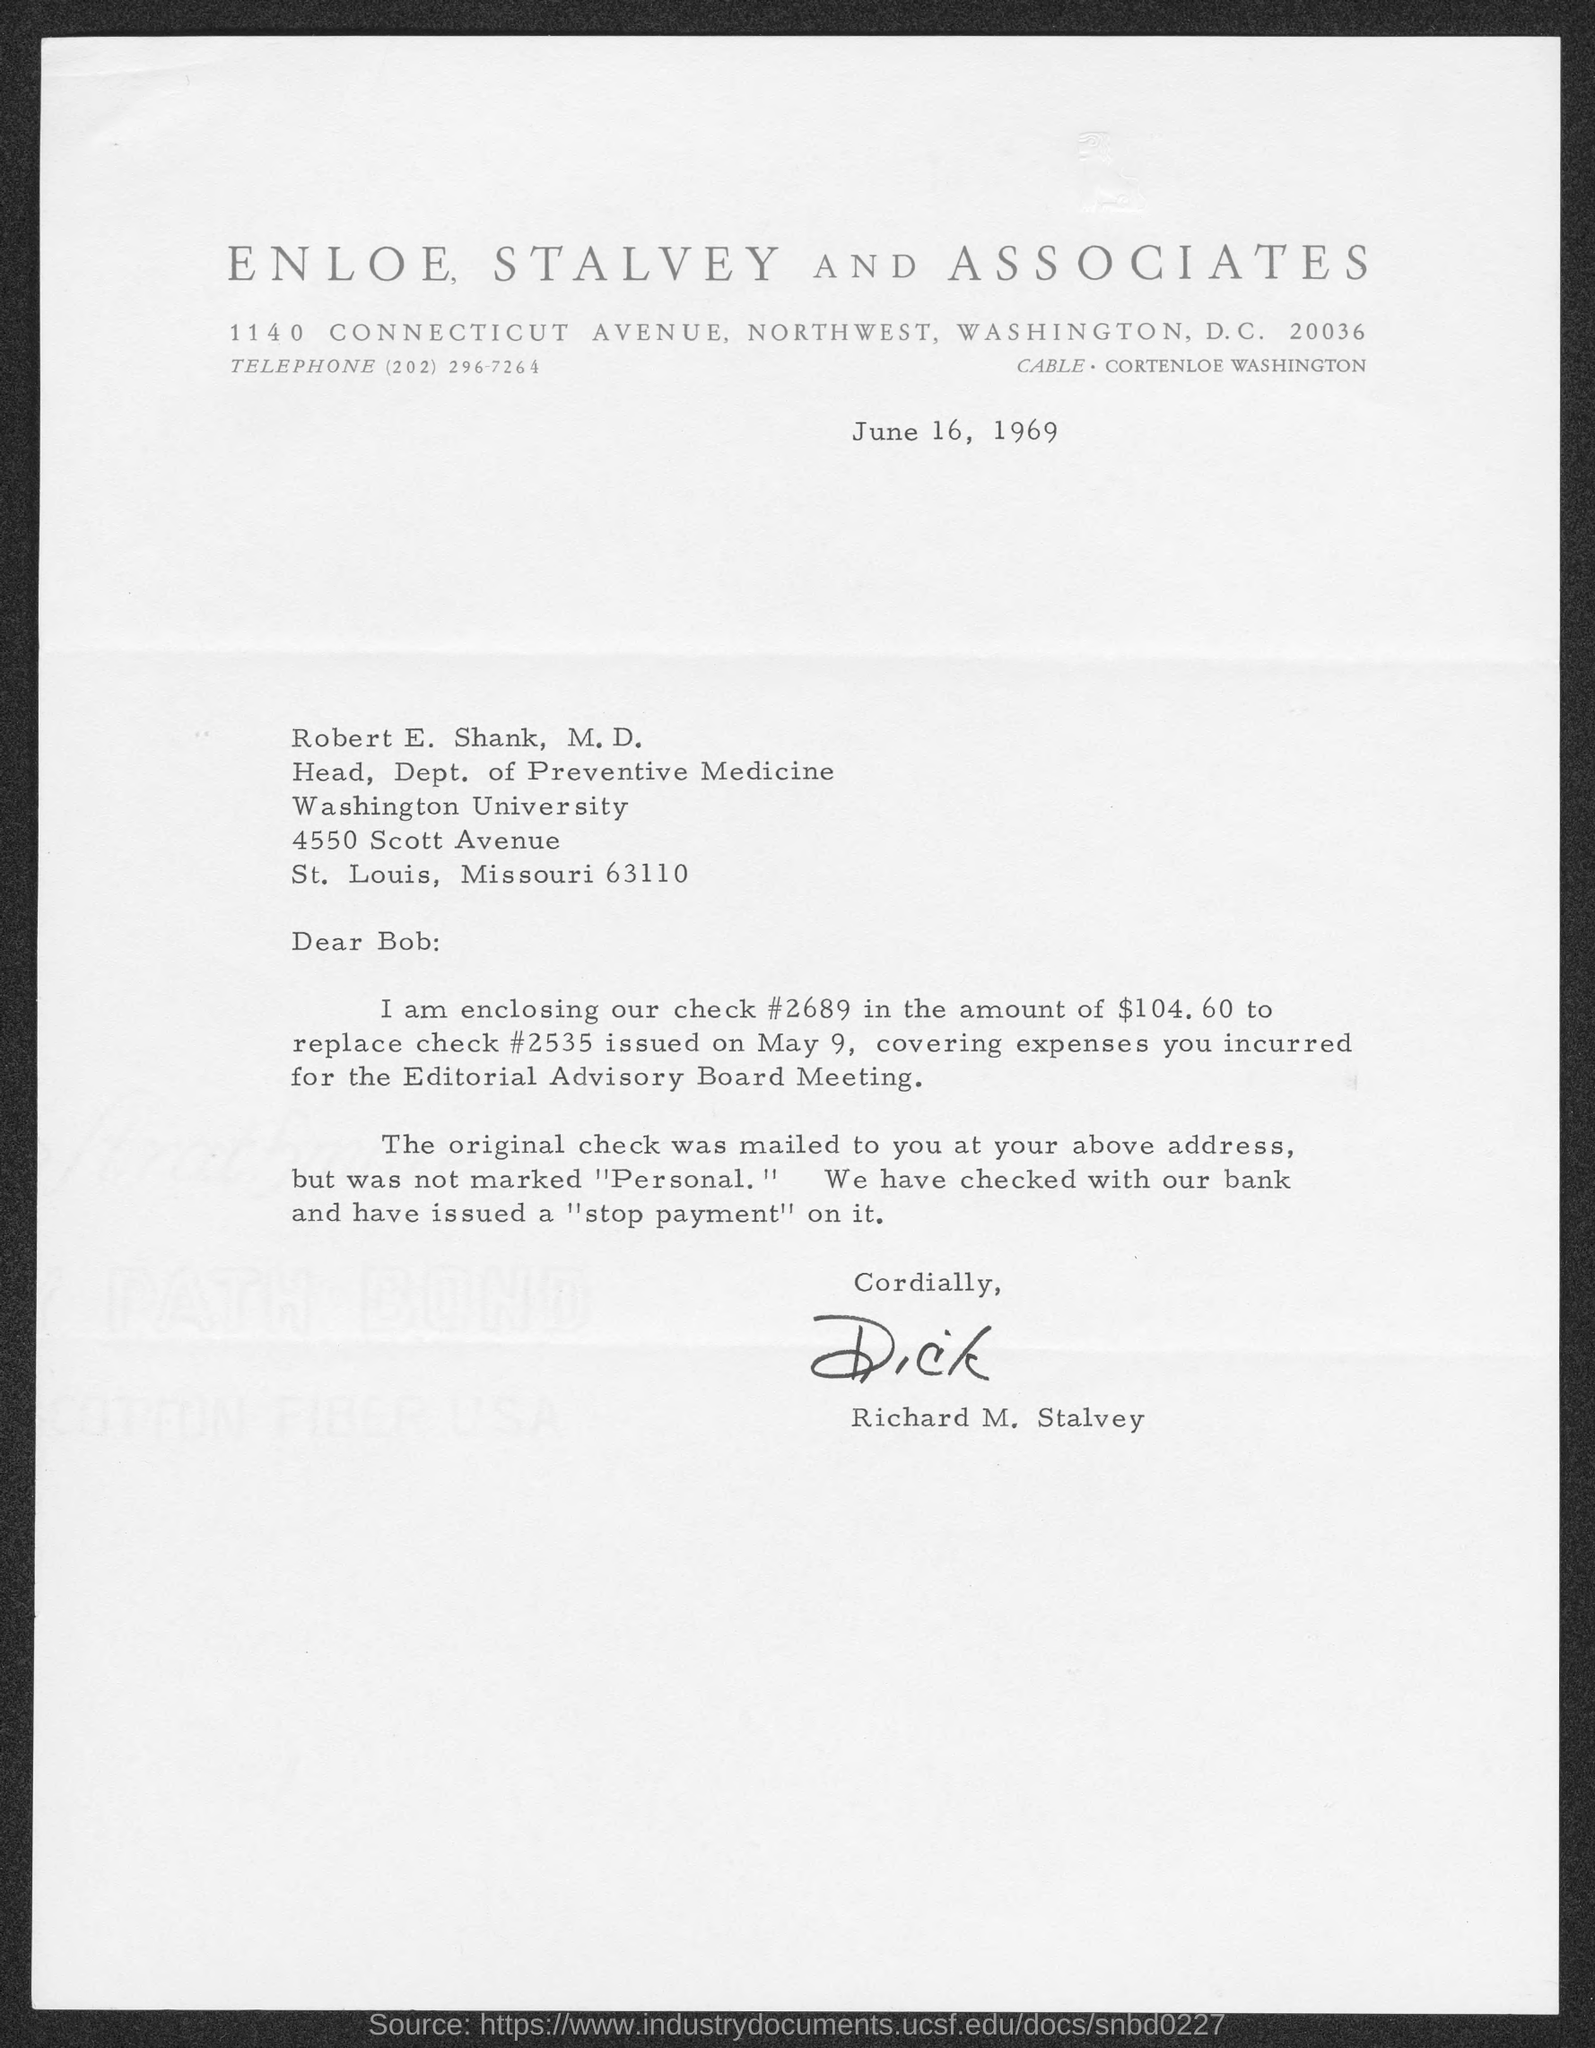What is the address of enloe, stalvey and associates?
Ensure brevity in your answer.  1140 Connecticut Avenue, Northwest, Washington D.C. 20036. What is the telephone number of enloe, stalvey and associates?
Provide a short and direct response. (202) 296-7264. The letter is dated on?
Your answer should be very brief. June 16, 1969. To whom is this letter written to?
Keep it short and to the point. Robert E. Shank, M.D. What is the position of robert e. shank, m.d.?
Your response must be concise. Head, Dept. of Preventive Medicine. Who wrote this letter?
Ensure brevity in your answer.  Richard M. Stalvey. 